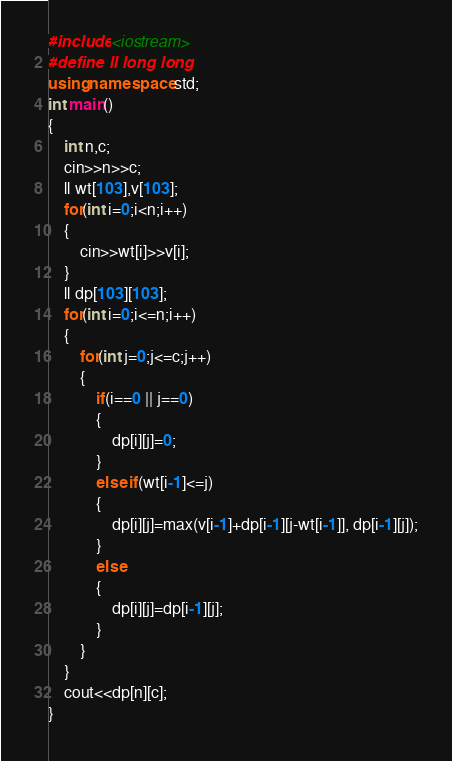<code> <loc_0><loc_0><loc_500><loc_500><_C++_>#include <iostream>
#define ll long long 
using namespace std;
int main() 
{
    int n,c;
    cin>>n>>c;
    ll wt[103],v[103];
    for(int i=0;i<n;i++)
    {
        cin>>wt[i]>>v[i];
    }
    ll dp[103][103];
    for(int i=0;i<=n;i++)
    {
        for(int j=0;j<=c;j++)
        {
            if(i==0 || j==0)
            {
                dp[i][j]=0;
            }
            else if(wt[i-1]<=j)
            {
                dp[i][j]=max(v[i-1]+dp[i-1][j-wt[i-1]], dp[i-1][j]);
            }
            else
            {
                dp[i][j]=dp[i-1][j];
            }
        }
    }
    cout<<dp[n][c];
}
</code> 